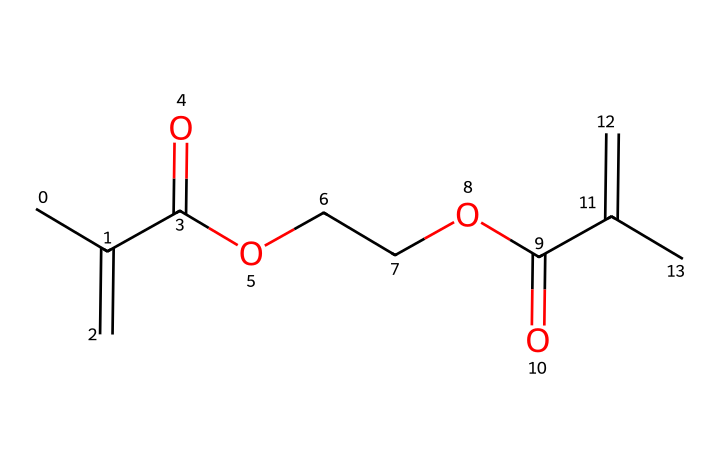What is the highest number of carbon atoms in this structure? The SMILES representation shows multiple carbon atoms connected through single and double bonds. By counting the 'C' symbols in the structure, the highest count is determined to be 10.
Answer: 10 How many ester functional groups are present in this chemical? The presence of ester functional groups can be identified by the sequence 'OCCO' and additional 'C(=O)O' sections in the SMILES. By examining the structure, it is evident that there are two ester groups.
Answer: 2 Which type of molecule is represented by this structure? This structure represents a photoresist used in UV-curable applications, as indicated by its polymeric components and functional groups suited for light-sensitive reactions.
Answer: photoresist What is the total number of double bonds in the given chemical? In the provided SMILES, there are two 'C(=C)' notations indicating carbon-carbon double bonds. Additionally, there are carbonyl groups (C=O), which are considered double bonds too. The total counts lead us to three explicit double bonds.
Answer: 3 What is the role of the carbonyl group in photoresist applications? The carbonyl group (C=O) plays a critical role in absorption of UV light, which is essential for the curing process in photoresist formulations. This functional group facilitates the polymerization reaction when exposed to UV radiation.
Answer: absorption How many oxygen atoms are there in this chemical structure? The count of 'O' in the SMILES representation reveals that there are four oxygen atoms present, as identified in the ester linkages and carbonyl groups.
Answer: 4 What is the likely primary use of this chemical compound in art restoration? This compound is primarily used as a protective layer in art restoration, providing a stable medium that cures under UV light, ensuring both adhesion and protection of restored works.
Answer: protective layer 